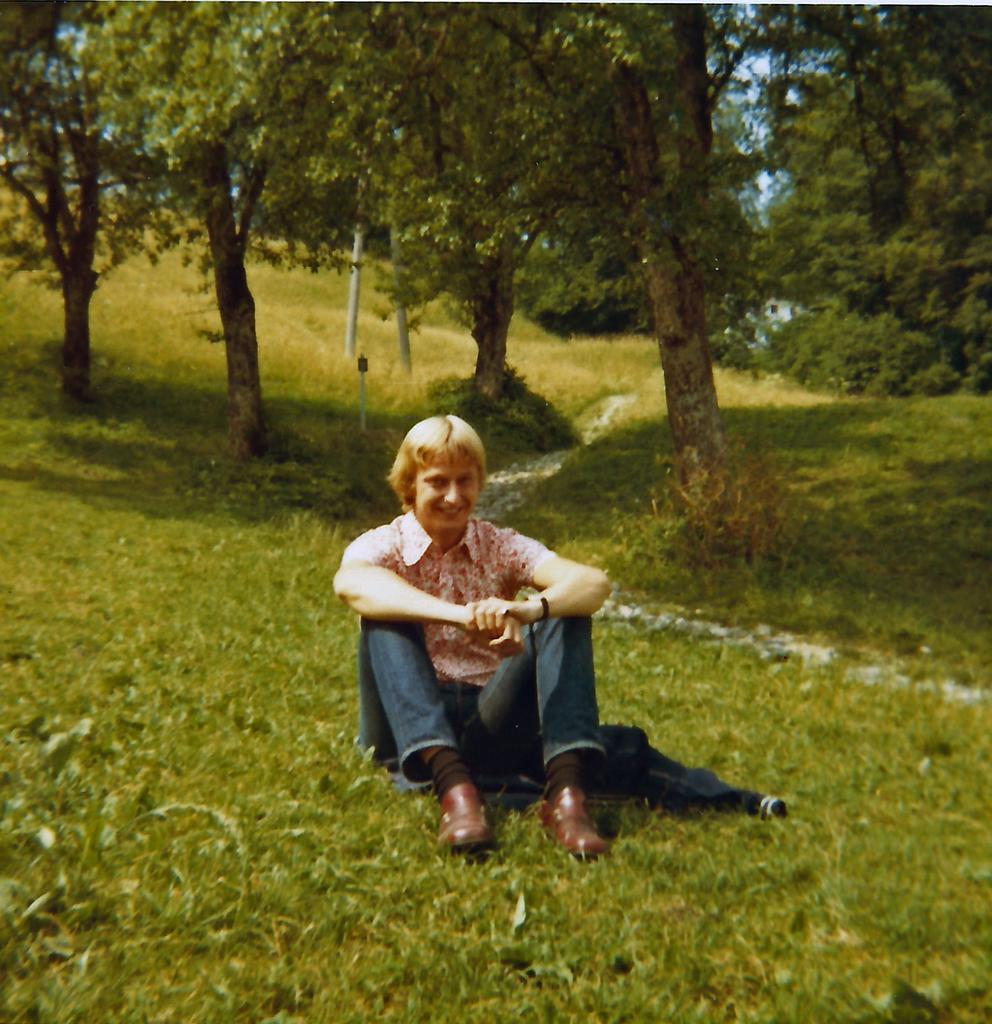What type of surface is on the ground in the image? There is grass on the ground in the image. What is the person in the image doing? The person is sitting in the image. What is the person's facial expression in the image? The person is smiling in the image. What can be seen in the background of the image? There are trees in the background of the image. What type of whip is being used by the person in the image? There is no whip present in the image; the person is simply sitting and smiling. 